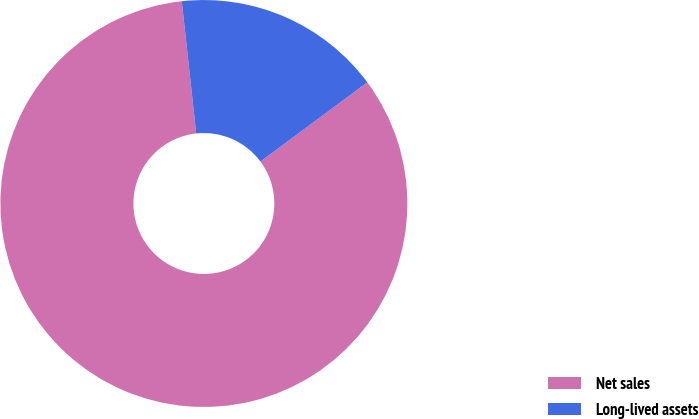Convert chart. <chart><loc_0><loc_0><loc_500><loc_500><pie_chart><fcel>Net sales<fcel>Long-lived assets<nl><fcel>83.42%<fcel>16.58%<nl></chart> 